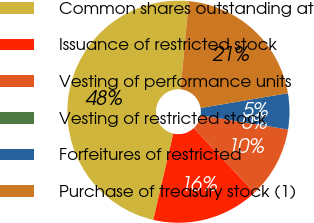Convert chart. <chart><loc_0><loc_0><loc_500><loc_500><pie_chart><fcel>Common shares outstanding at<fcel>Issuance of restricted stock<fcel>Vesting of performance units<fcel>Vesting of restricted stock<fcel>Forfeitures of restricted<fcel>Purchase of treasury stock (1)<nl><fcel>47.87%<fcel>15.63%<fcel>10.43%<fcel>0.01%<fcel>5.22%<fcel>20.84%<nl></chart> 